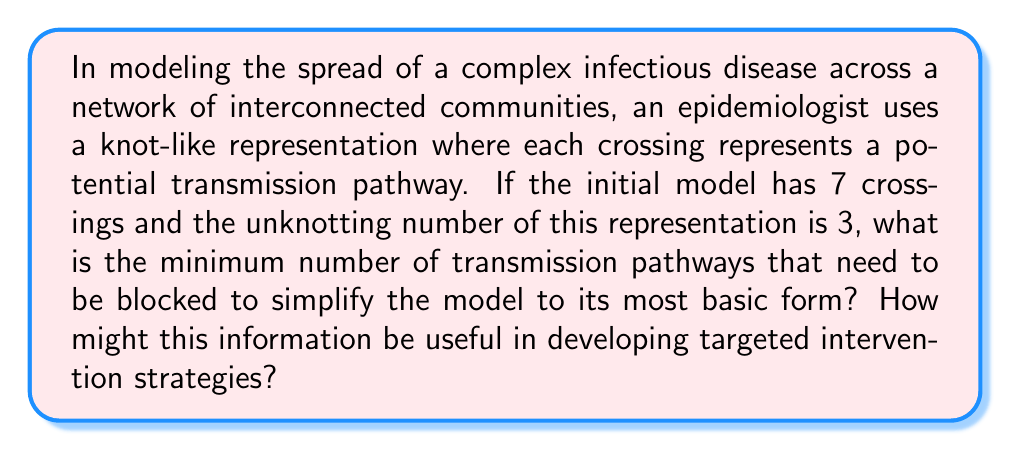Provide a solution to this math problem. To solve this problem, we need to understand the concept of unknotting number and its application to epidemiological models:

1) In knot theory, the unknotting number $u(K)$ of a knot $K$ is the minimum number of times the knot must be passed through itself to untie it completely.

2) In our epidemiological model, each crossing represents a potential transmission pathway, and the unknotting number represents the minimum number of pathways that need to be blocked to simplify the model to its most basic form.

3) Given:
   - Initial model has 7 crossings
   - Unknotting number $u(K) = 3$

4) The unknotting number directly corresponds to the minimum number of transmission pathways that need to be blocked. Therefore, 3 pathways need to be blocked to simplify the model.

5) Usefulness in developing targeted intervention strategies:
   a) Identifies critical transmission pathways: By focusing on these 3 key pathways, interventions can be more targeted and efficient.
   b) Resource allocation: Limited resources can be directed to the most impactful interventions.
   c) Simplified modeling: Blocking these pathways allows for a simpler model, potentially making future predictions more manageable.
   d) Prioritization: Helps prioritize which communities or connections to focus on for maximum impact.
Answer: 3 pathways; Enables targeted, efficient interventions 